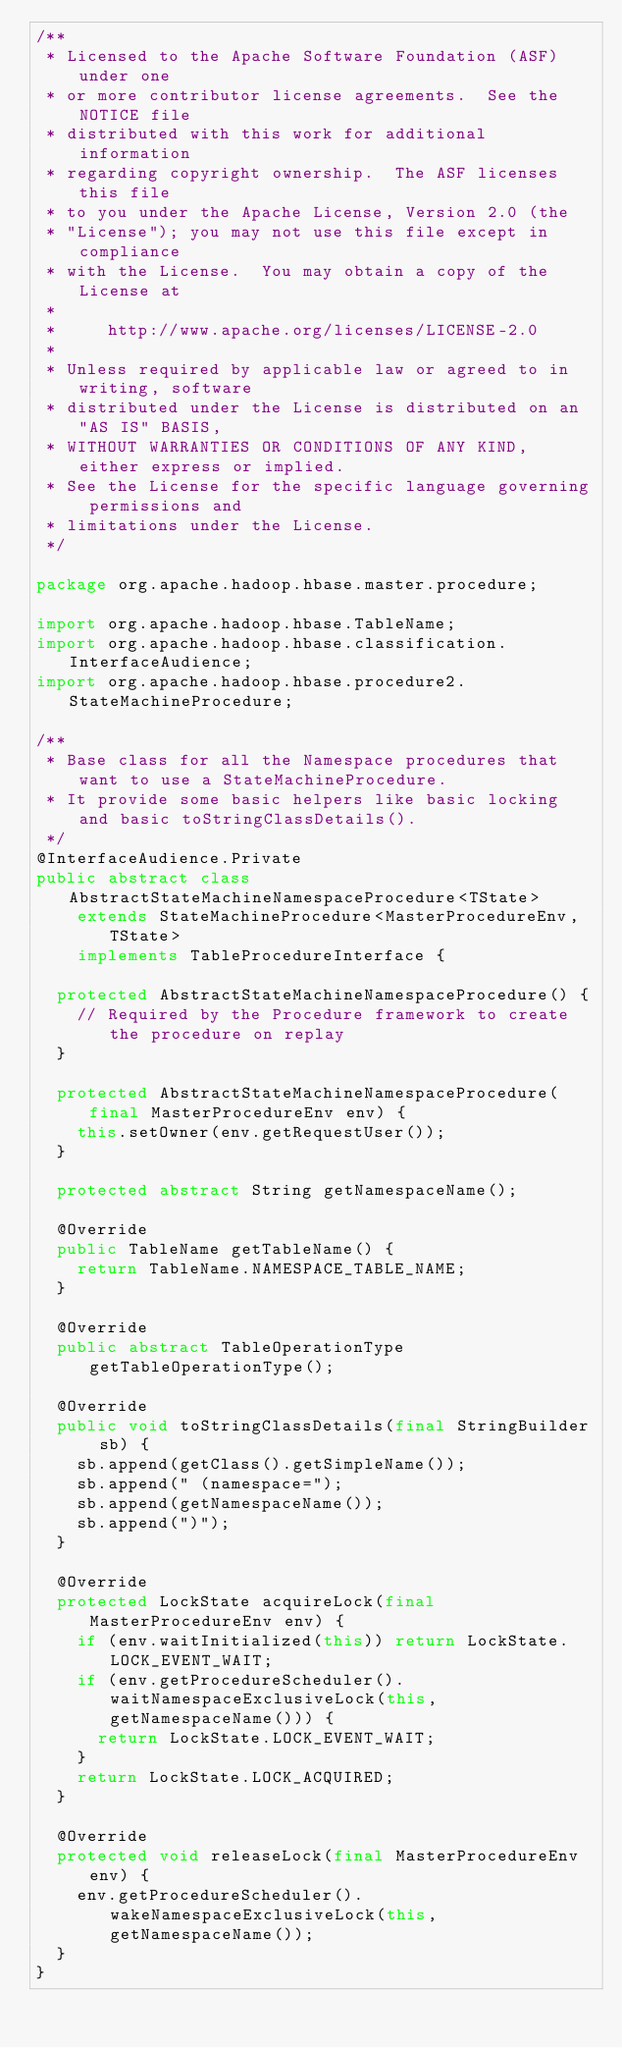Convert code to text. <code><loc_0><loc_0><loc_500><loc_500><_Java_>/**
 * Licensed to the Apache Software Foundation (ASF) under one
 * or more contributor license agreements.  See the NOTICE file
 * distributed with this work for additional information
 * regarding copyright ownership.  The ASF licenses this file
 * to you under the Apache License, Version 2.0 (the
 * "License"); you may not use this file except in compliance
 * with the License.  You may obtain a copy of the License at
 *
 *     http://www.apache.org/licenses/LICENSE-2.0
 *
 * Unless required by applicable law or agreed to in writing, software
 * distributed under the License is distributed on an "AS IS" BASIS,
 * WITHOUT WARRANTIES OR CONDITIONS OF ANY KIND, either express or implied.
 * See the License for the specific language governing permissions and
 * limitations under the License.
 */

package org.apache.hadoop.hbase.master.procedure;

import org.apache.hadoop.hbase.TableName;
import org.apache.hadoop.hbase.classification.InterfaceAudience;
import org.apache.hadoop.hbase.procedure2.StateMachineProcedure;

/**
 * Base class for all the Namespace procedures that want to use a StateMachineProcedure.
 * It provide some basic helpers like basic locking and basic toStringClassDetails().
 */
@InterfaceAudience.Private
public abstract class AbstractStateMachineNamespaceProcedure<TState>
    extends StateMachineProcedure<MasterProcedureEnv, TState>
    implements TableProcedureInterface {

  protected AbstractStateMachineNamespaceProcedure() {
    // Required by the Procedure framework to create the procedure on replay
  }

  protected AbstractStateMachineNamespaceProcedure(final MasterProcedureEnv env) {
    this.setOwner(env.getRequestUser());
  }

  protected abstract String getNamespaceName();

  @Override
  public TableName getTableName() {
    return TableName.NAMESPACE_TABLE_NAME;
  }

  @Override
  public abstract TableOperationType getTableOperationType();

  @Override
  public void toStringClassDetails(final StringBuilder sb) {
    sb.append(getClass().getSimpleName());
    sb.append(" (namespace=");
    sb.append(getNamespaceName());
    sb.append(")");
  }

  @Override
  protected LockState acquireLock(final MasterProcedureEnv env) {
    if (env.waitInitialized(this)) return LockState.LOCK_EVENT_WAIT;
    if (env.getProcedureScheduler().waitNamespaceExclusiveLock(this, getNamespaceName())) {
      return LockState.LOCK_EVENT_WAIT;
    }
    return LockState.LOCK_ACQUIRED;
  }

  @Override
  protected void releaseLock(final MasterProcedureEnv env) {
    env.getProcedureScheduler().wakeNamespaceExclusiveLock(this, getNamespaceName());
  }
}</code> 